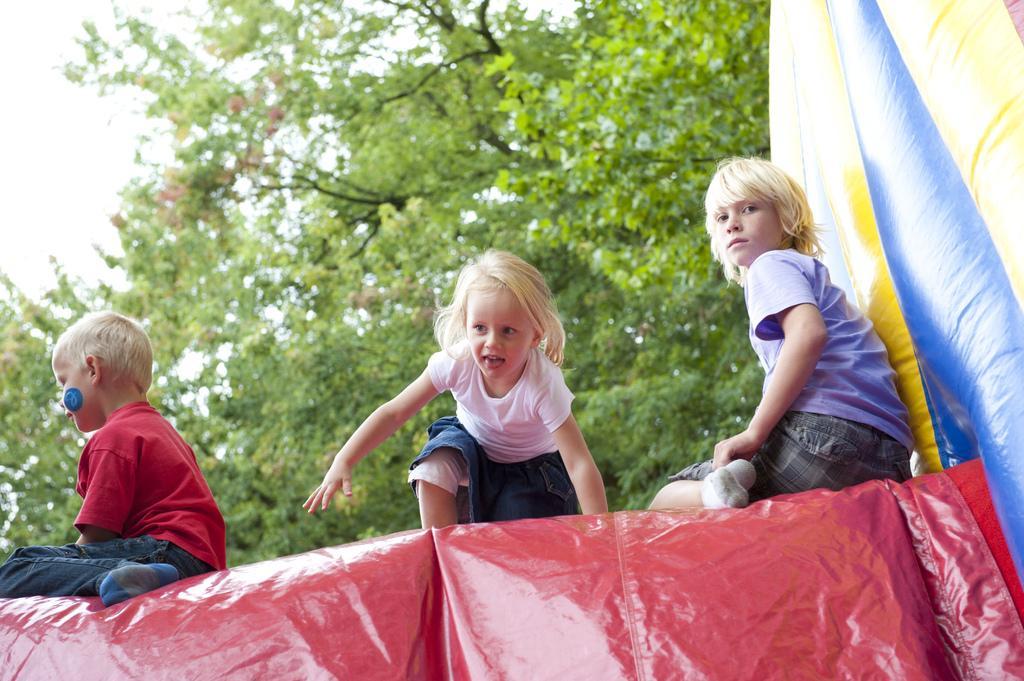Can you describe this image briefly? In the center of the image three childs are there. At the bottom of the image balloon castle are there. In the background of the image tree is there. At the top left corner sky is there. 